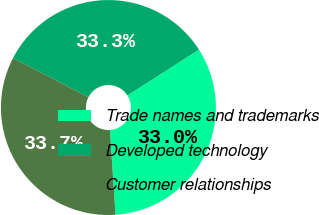<chart> <loc_0><loc_0><loc_500><loc_500><pie_chart><fcel>Trade names and trademarks<fcel>Developed technology<fcel>Customer relationships<nl><fcel>33.0%<fcel>33.33%<fcel>33.66%<nl></chart> 